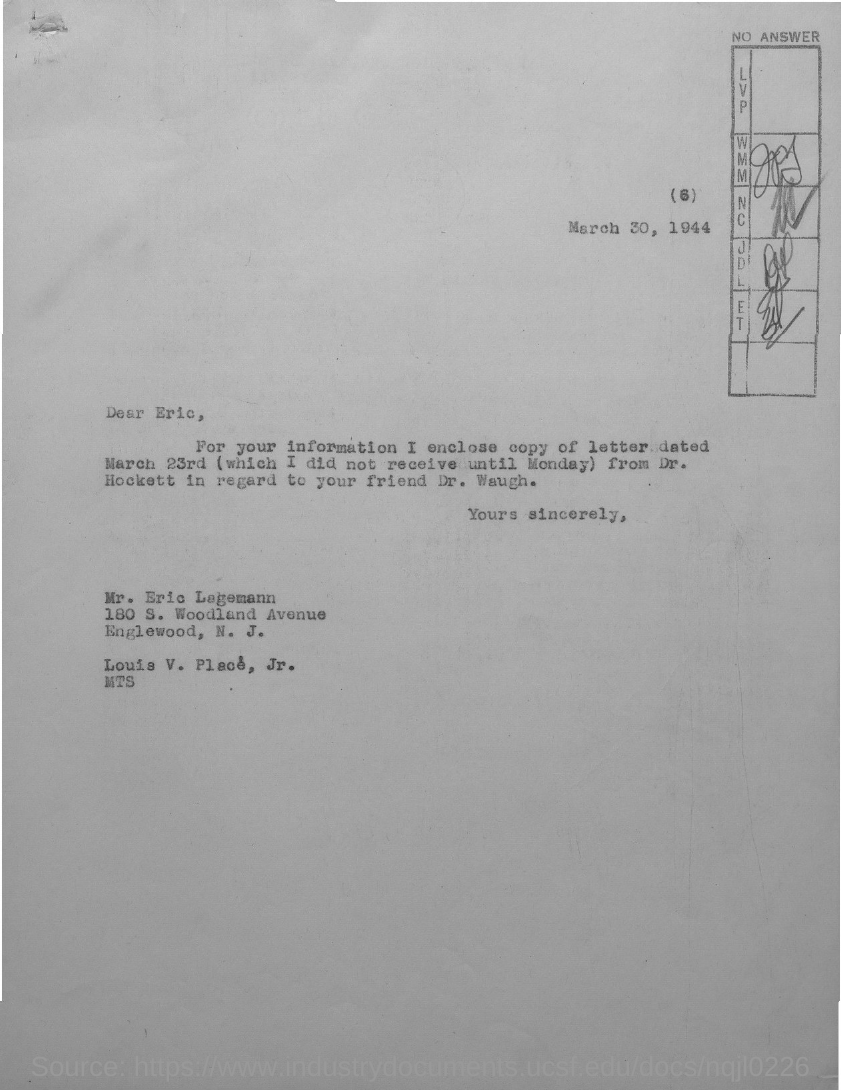The letter is addressed to which person?
Keep it short and to the point. Eric Legemann. 